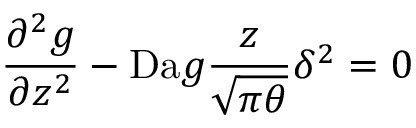<formula> <loc_0><loc_0><loc_500><loc_500>\frac { \partial ^ { 2 } g } { \partial z ^ { 2 } } - D a g \frac { z } { \sqrt { \pi \theta } } \delta ^ { 2 } = 0</formula> 